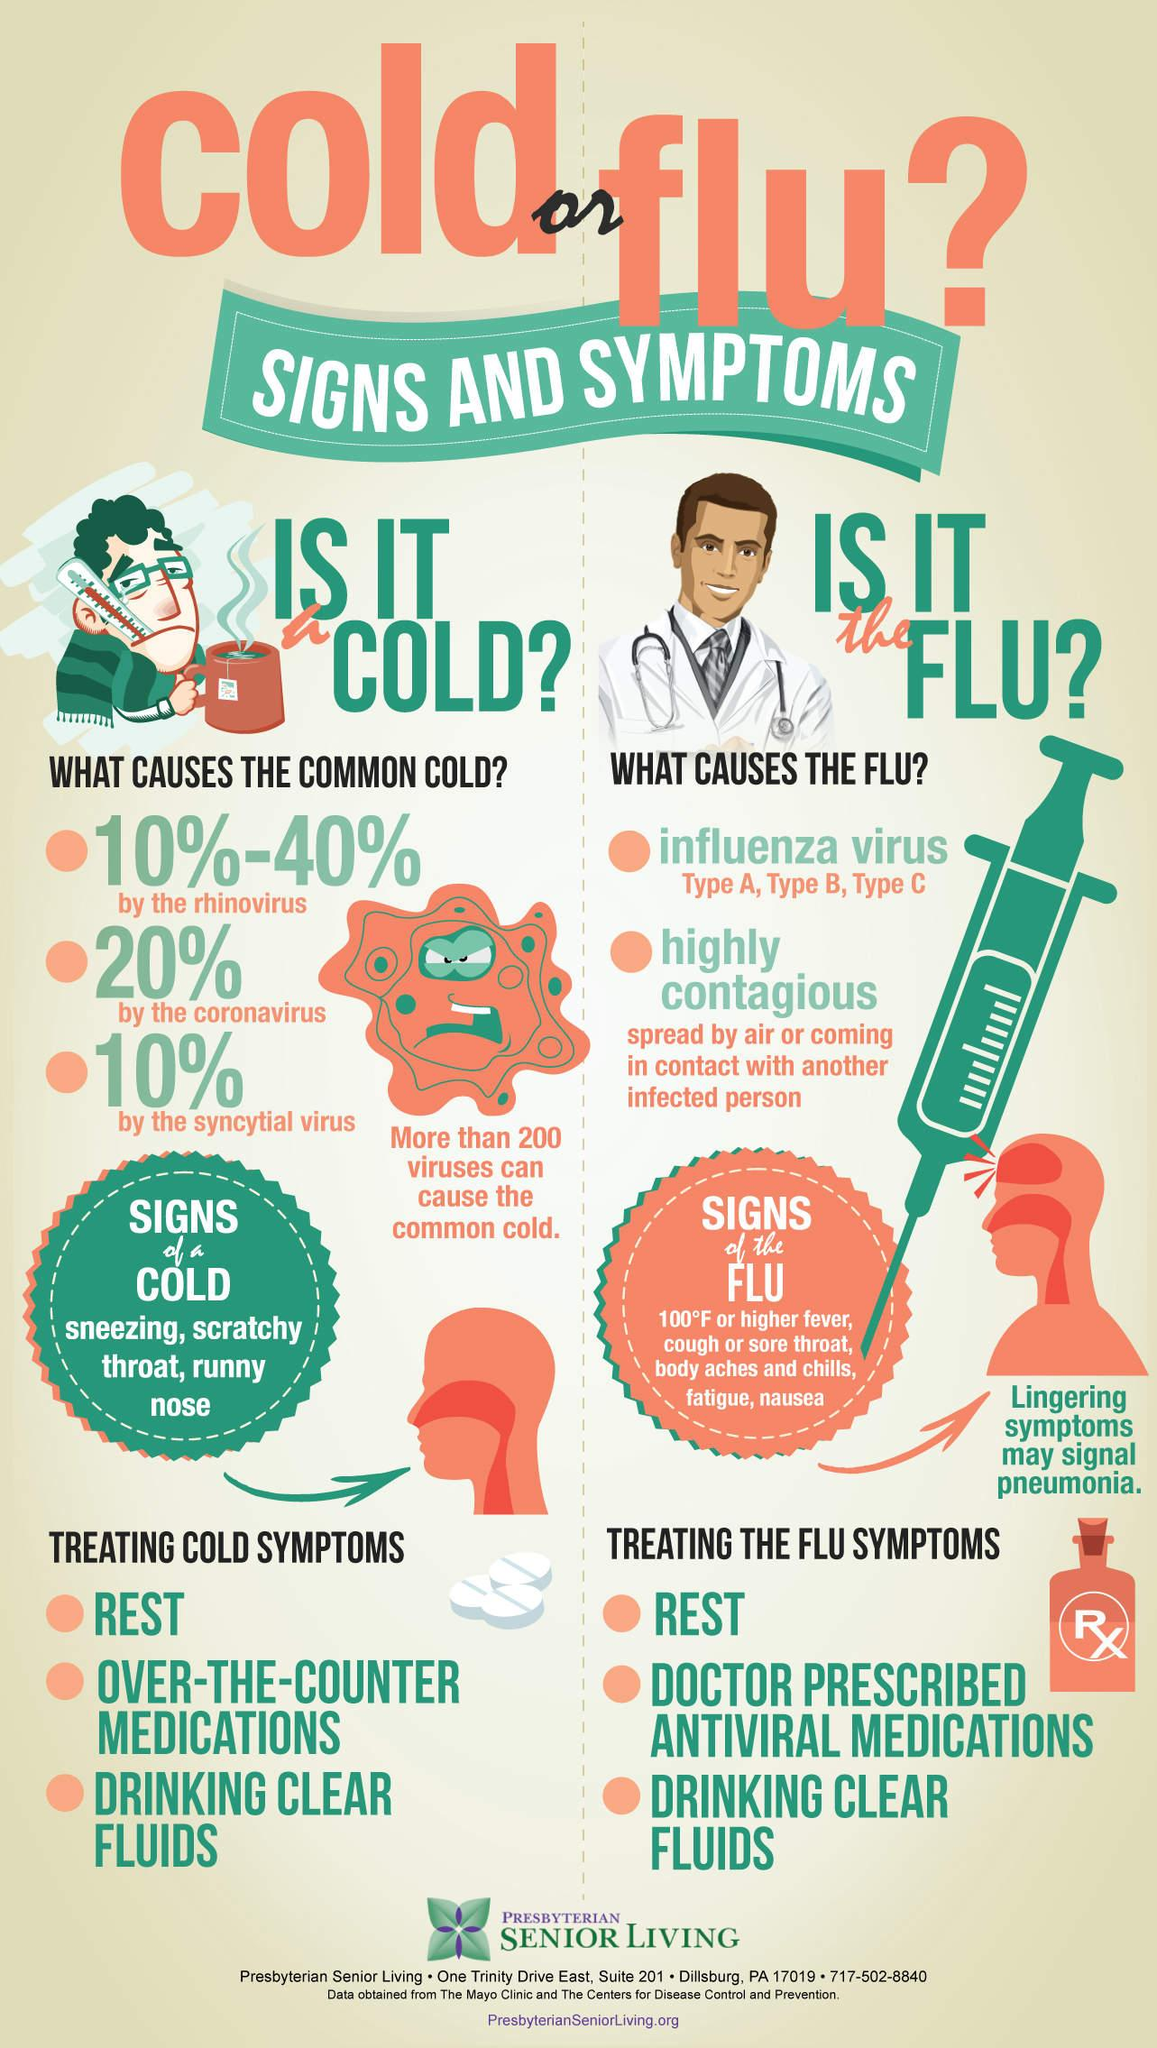Point out several critical features in this image. According to studies, the rhinovirus is believed to cause between 10% and 40% of common cold cases. REST and DRINKING CLEAR FLUIDS are commonly used treatment methods for both cold and flu symptoms. The common cold is caused by the syncytial virus in 10% of cases. Antiviral medications are the most effective treatment for flu symptoms. Rhinovirus, coronavirus, and syncytial virus are viruses that are responsible for causing the common cold. 